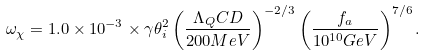Convert formula to latex. <formula><loc_0><loc_0><loc_500><loc_500>\omega _ { \chi } = 1 . 0 \times 1 0 ^ { - 3 } \times \gamma \theta _ { i } ^ { 2 } \left ( \frac { \Lambda _ { Q } C D } { 2 0 0 M e V } \right ) ^ { - 2 / 3 } \left ( \frac { f _ { a } } { 1 0 ^ { 1 0 } G e V } \right ) ^ { 7 / 6 } .</formula> 